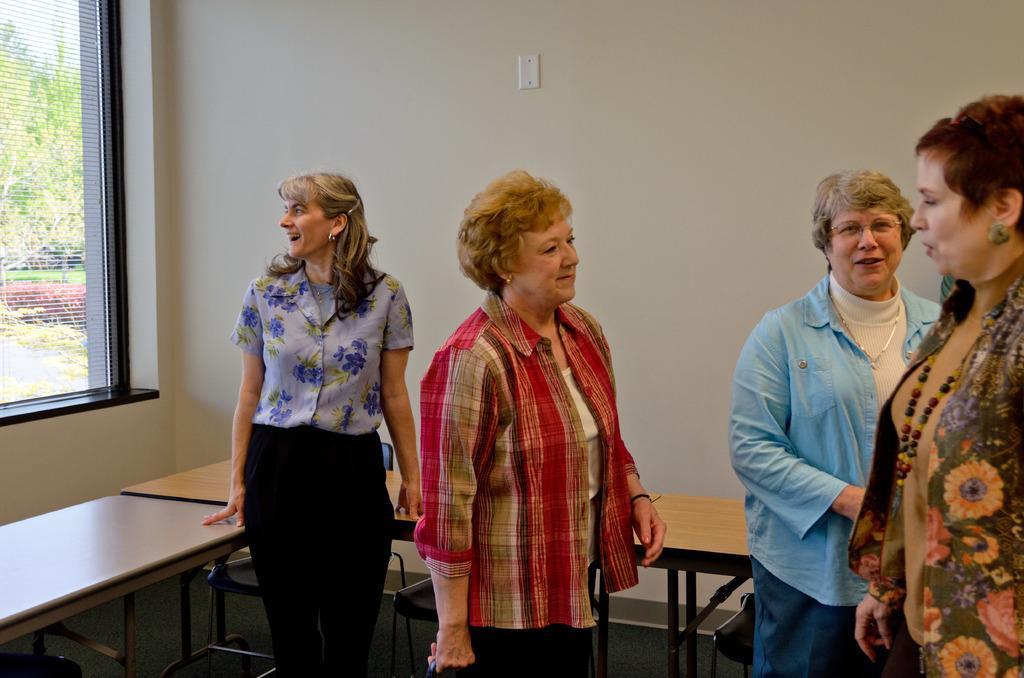Describe this image in one or two sentences. In a room there are four women, they are talking to each other and behind them there are table and in the background there is a wall. On the left side there is a window. 